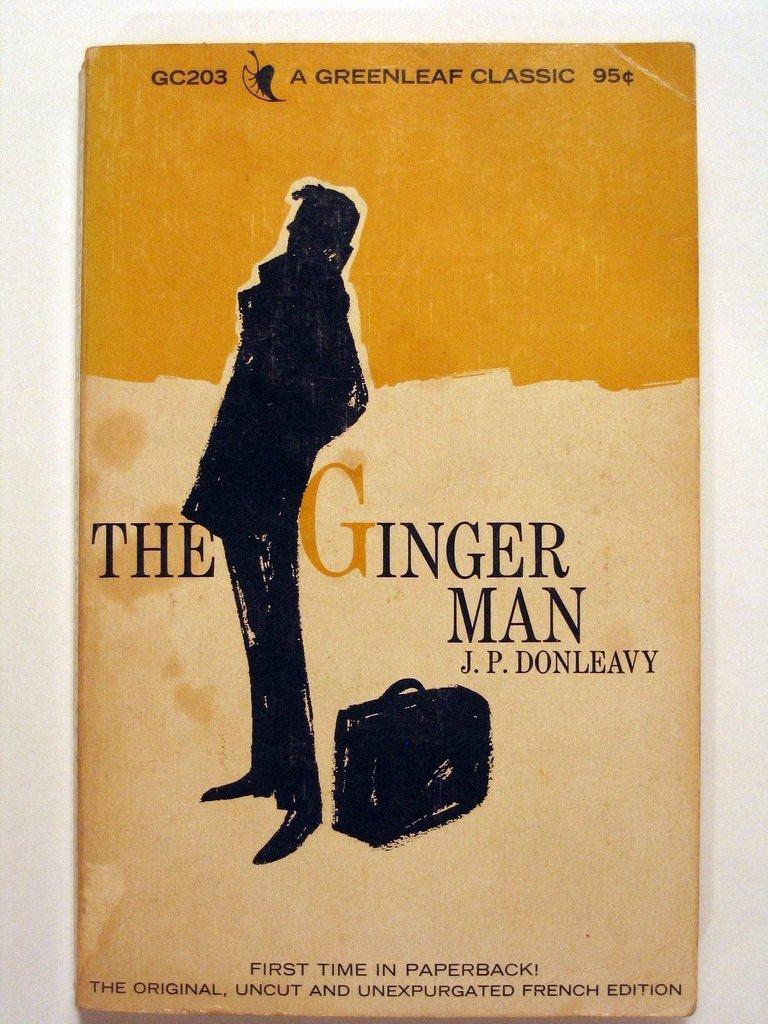In one or two sentences, can you explain what this image depicts? In this picture we can see a book cover and on the cover there is a person, a bag and some words. 